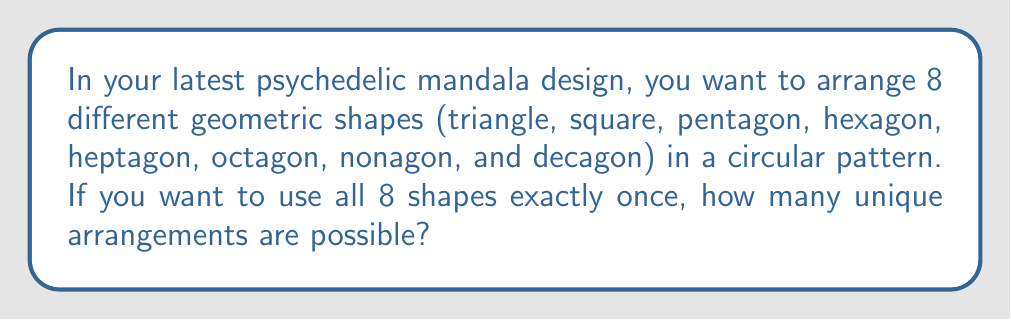Give your solution to this math problem. Let's approach this step-by-step:

1) This problem is a classic example of a circular permutation. In a circular permutation, rotations of the same arrangement are considered identical.

2) Normally, with 8 different objects, we would have 8! (8 factorial) permutations.

3) However, in a circular arrangement, all rotations of a particular arrangement are considered the same. There are 8 possible rotations for each unique arrangement (as there are 8 positions).

4) Therefore, we need to divide the total number of linear permutations by the number of rotations:

   $$\text{Number of unique circular arrangements} = \frac{\text{Number of linear permutations}}{\text{Number of rotations}}$$

5) Mathematically, this is expressed as:

   $$\text{Number of unique circular arrangements} = \frac{8!}{8} = (8-1)! = 7!$$

6) Let's calculate this:
   
   $$7! = 7 \times 6 \times 5 \times 4 \times 3 \times 2 \times 1 = 5040$$

Thus, there are 5040 unique ways to arrange the 8 geometric shapes in your mandala design.
Answer: 5040 